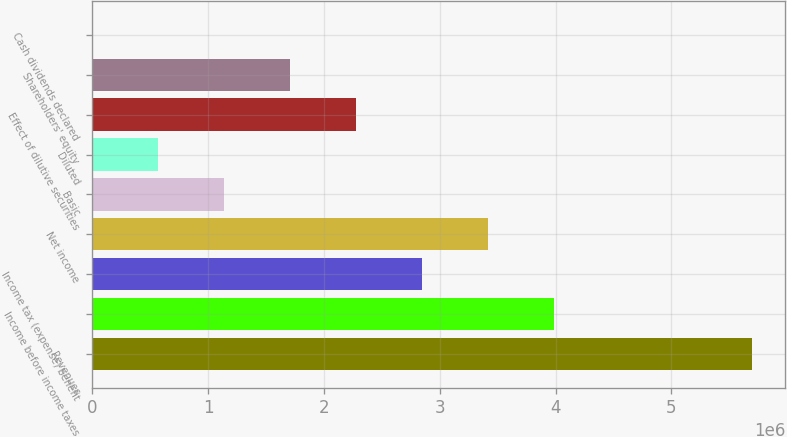<chart> <loc_0><loc_0><loc_500><loc_500><bar_chart><fcel>Revenues<fcel>Income before income taxes<fcel>Income tax (expense) benefit<fcel>Net income<fcel>Basic<fcel>Diluted<fcel>Effect of dilutive securities<fcel>Shareholders' equity<fcel>Cash dividends declared<nl><fcel>5.70034e+06<fcel>3.99024e+06<fcel>2.85017e+06<fcel>3.4202e+06<fcel>1.14007e+06<fcel>570034<fcel>2.28014e+06<fcel>1.7101e+06<fcel>0.23<nl></chart> 